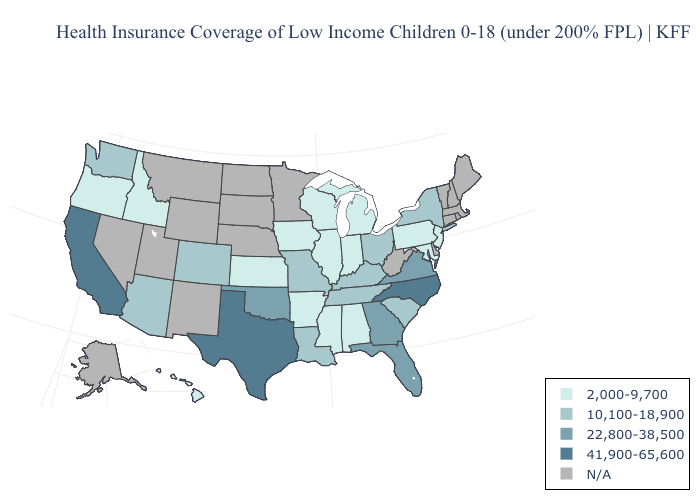Among the states that border West Virginia , which have the lowest value?
Give a very brief answer. Maryland, Pennsylvania. Name the states that have a value in the range 41,900-65,600?
Answer briefly. California, North Carolina, Texas. Among the states that border New Mexico , does Oklahoma have the lowest value?
Be succinct. No. What is the lowest value in states that border Georgia?
Answer briefly. 2,000-9,700. What is the value of Delaware?
Be succinct. N/A. What is the highest value in the USA?
Give a very brief answer. 41,900-65,600. What is the highest value in the USA?
Be succinct. 41,900-65,600. Which states hav the highest value in the MidWest?
Write a very short answer. Missouri, Ohio. Does Ohio have the lowest value in the USA?
Be succinct. No. Among the states that border North Carolina , which have the lowest value?
Concise answer only. South Carolina, Tennessee. What is the lowest value in the MidWest?
Concise answer only. 2,000-9,700. What is the lowest value in states that border South Dakota?
Give a very brief answer. 2,000-9,700. What is the highest value in the West ?
Concise answer only. 41,900-65,600. Does Virginia have the lowest value in the USA?
Short answer required. No. Does the map have missing data?
Concise answer only. Yes. 